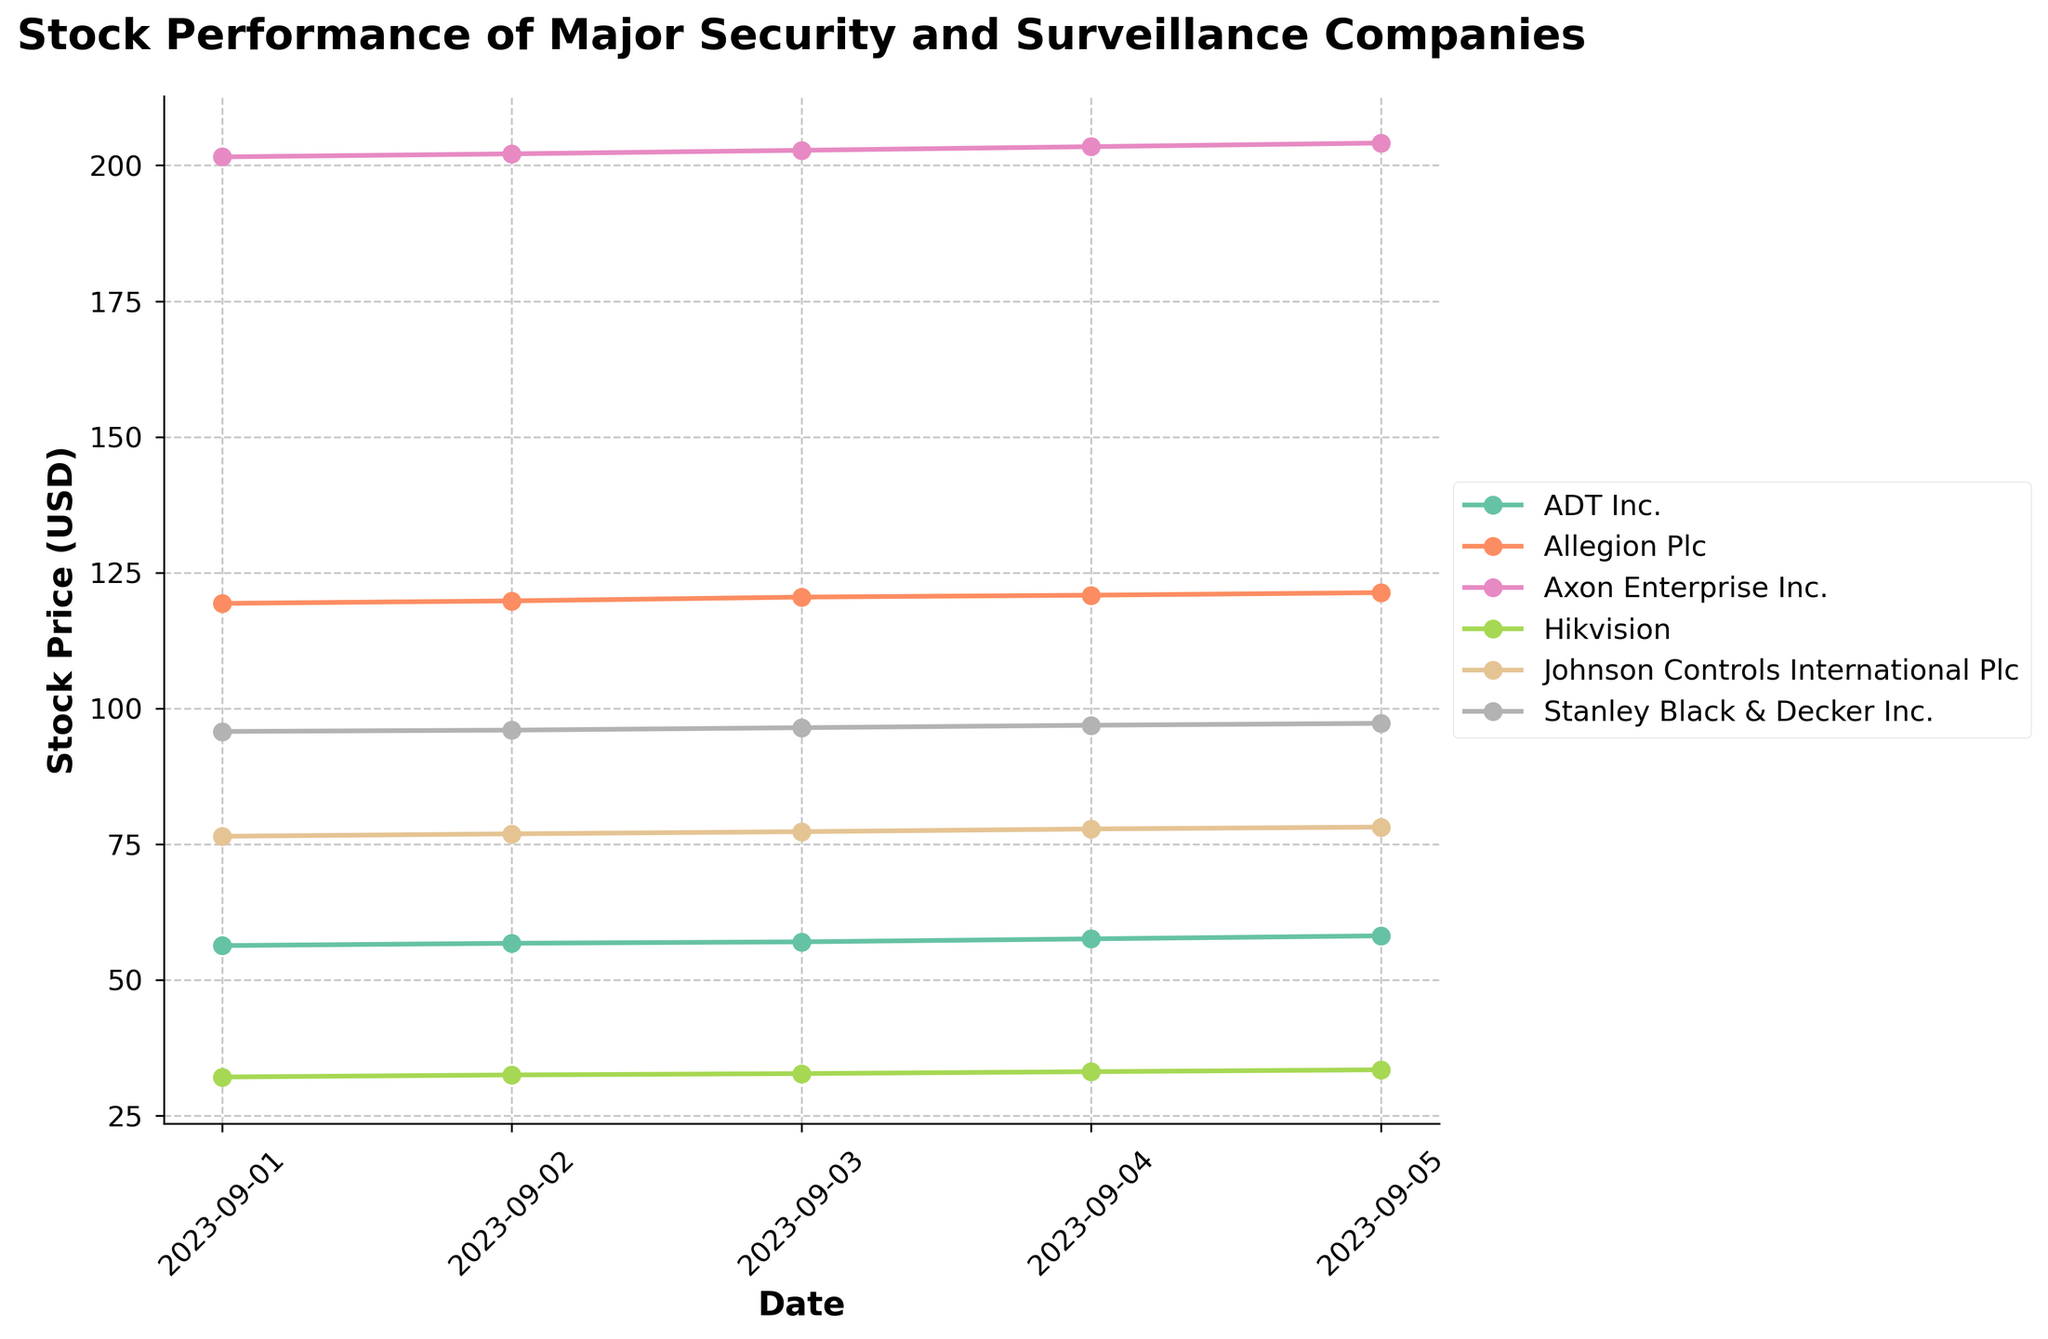What is the title of the figure? The title is displayed at the top of the figure, providing a summary of what the plot represents. From the data, the title is "Stock Performance of Major Security and Surveillance Companies".
Answer: Stock Performance of Major Security and Surveillance Companies Which company had the highest stock price on September 5, 2023? Look for the company whose stock price is maximal on the September 5, 2023, among all companies displayed. The stock prices on September 5, 2023 are: ADT Inc. - 58.12, Allegion Plc - 121.32, Axon Enterprise Inc. - 204.12, Hikvision - 33.45, Johnson Controls International Plc - 78.15, Stanley Black & Decker Inc. - 97.25. Axon Enterprise Inc. has the highest stock price of 204.12.
Answer: Axon Enterprise Inc What is the trend of Johnson Controls International Plc's stock price over the given dates? Observe Johnson Controls International Plc's stock price values sequentially for the dates provided: 76.45, 76.90, 77.30, 77.80, 78.15. The values are incrementally increasing each day, indicating an upward trend.
Answer: Upward trend By how much did ADT Inc.'s stock price increase from September 1 to September 5? Subtract ADT Inc.'s stock price on September 1 (56.32) from the stock price on September 5 (58.12). The difference is 58.12 - 56.32 = 1.8.
Answer: 1.8 Which company had the most stable stock price over the given dates, considering the range of prices? Identify the range (difference between highest and lowest stock prices) for each company:
- ADT Inc.: 58.12 - 56.32 = 1.8
- Allegion Plc: 121.32 - 119.34 = 1.98
- Axon Enterprise Inc.: 204.12 - 201.56 = 2.56
- Hikvision: 33.45 - 32.12 = 1.33
- Johnson Controls International Plc: 78.15 - 76.45 = 1.7
- Stanley Black & Decker Inc.: 97.25 - 95.75 = 1.5
Hikvision has the smallest range of 1.33.
Answer: Hikvision How did Allegion Plc's stock price change from September 3 to September 5? Check Allegion Plc's stock price on September 3 (120.50) and on September 5 (121.32). The increase is 121.32 - 120.50 = 0.82.
Answer: Increased by 0.82 Which company experienced the highest percentage increase in stock price from September 1 to September 5? Calculate the percentage increase for each company:
- ADT Inc.: ((58.12 - 56.32) / 56.32) * 100 ≈ 3.19%
- Allegion Plc: ((121.32 - 119.34) / 119.34) * 100 ≈ 1.66%
- Axon Enterprise Inc.: ((204.12 - 201.56) / 201.56) * 100 ≈ 1.27%
- Hikvision: ((33.45 - 32.12) / 32.12) * 100 ≈ 4.14%
- Johnson Controls International Plc: ((78.15 - 76.45) / 76.45) * 100 ≈ 2.22%
- Stanley Black & Decker Inc.: ((97.25 - 95.75) / 95.75) * 100 ≈ 1.57%
Hikvision has the highest percentage increase of approximately 4.14%.
Answer: Hikvision What was the average stock price of Stanley Black & Decker Inc. over the given dates? Sum the stock prices of Stanley Black & Decker Inc.: 95.75 + 96.00 + 96.45 + 96.90 + 97.25 = 482.35. Calculate the average by dividing by the number of dates (5): 482.35 / 5 = 96.47.
Answer: 96.47 Which company's stock price had the highest variability over the given dates? Check the differences in stock prices over the dates for each company to find the one with the highest range:
- ADT Inc.: 58.12 - 56.32 = 1.8
- Allegion Plc: 121.32 - 119.34 = 1.98
- Axon Enterprise Inc.: 204.12 - 201.56 = 2.56
- Hikvision: 33.45 - 32.12 = 1.33
- Johnson Controls International Plc: 78.15 - 76.45 = 1.7
- Stanley Black & Decker Inc.: 97.25 - 95.75 = 1.5
Axon Enterprise Inc. has the highest range of 2.56.
Answer: Axon Enterprise Inc 